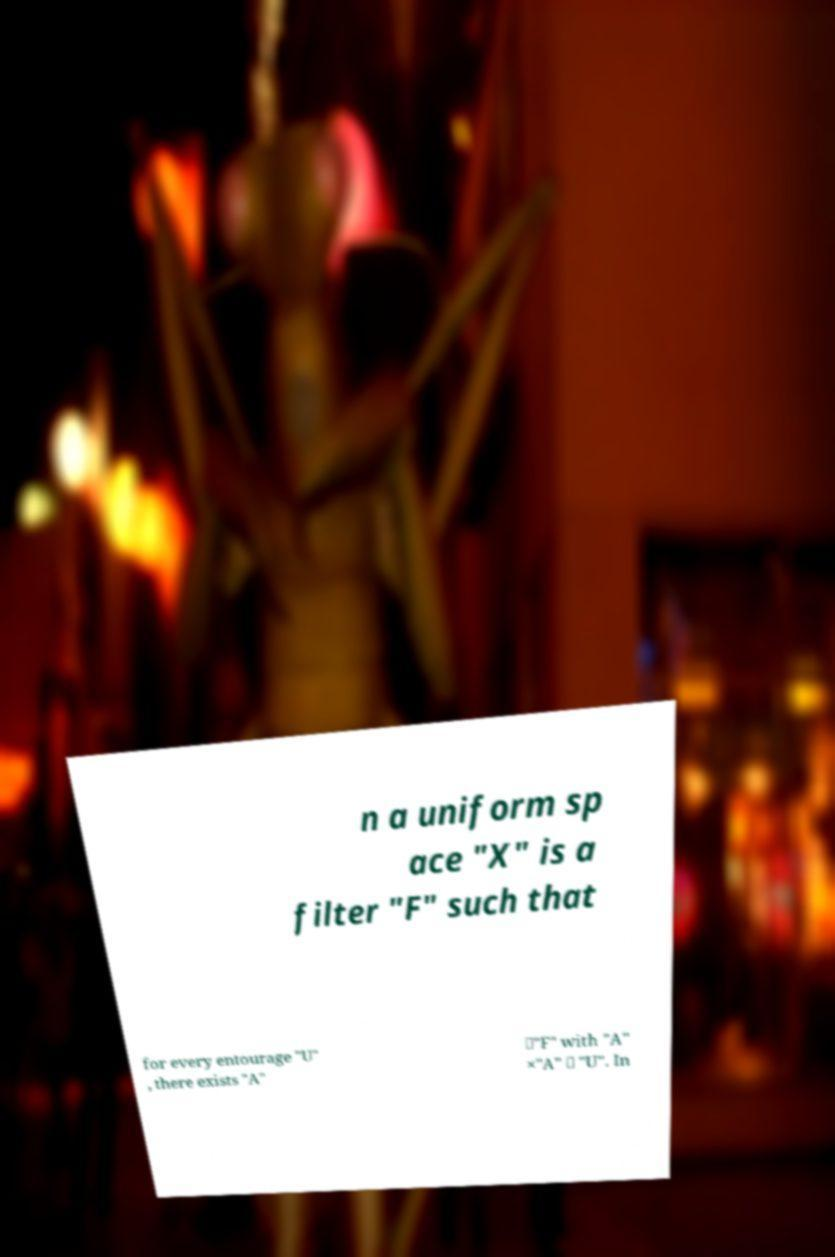Please read and relay the text visible in this image. What does it say? n a uniform sp ace "X" is a filter "F" such that for every entourage "U" , there exists "A" ∈"F" with "A" ×"A" ⊆ "U". In 